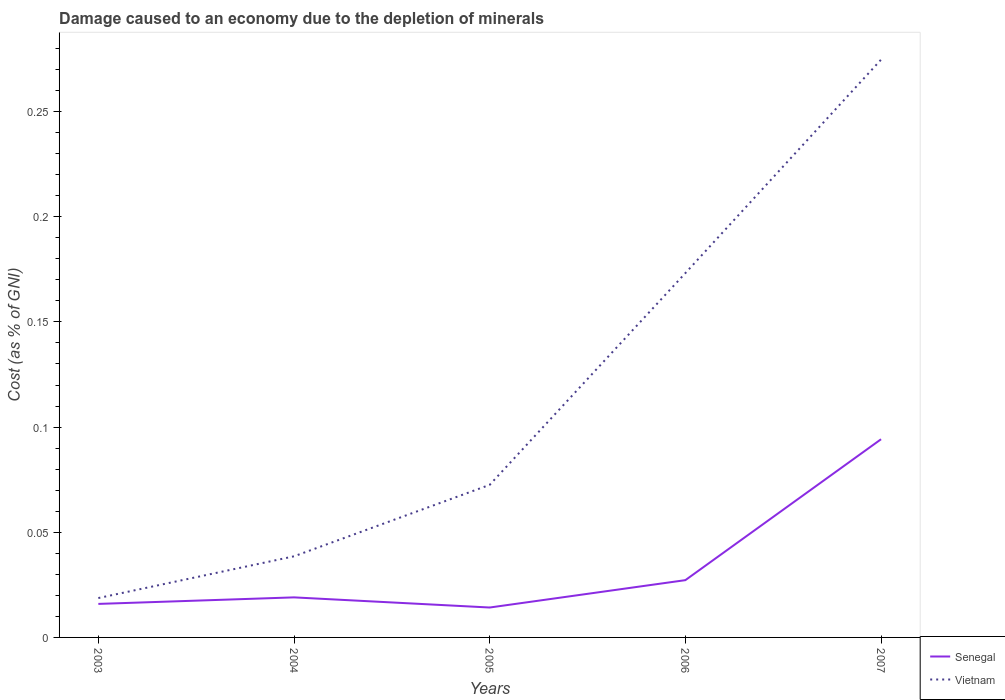Does the line corresponding to Vietnam intersect with the line corresponding to Senegal?
Ensure brevity in your answer.  No. Across all years, what is the maximum cost of damage caused due to the depletion of minerals in Vietnam?
Keep it short and to the point. 0.02. In which year was the cost of damage caused due to the depletion of minerals in Vietnam maximum?
Your answer should be very brief. 2003. What is the total cost of damage caused due to the depletion of minerals in Vietnam in the graph?
Give a very brief answer. -0.2. What is the difference between the highest and the second highest cost of damage caused due to the depletion of minerals in Vietnam?
Make the answer very short. 0.26. Is the cost of damage caused due to the depletion of minerals in Vietnam strictly greater than the cost of damage caused due to the depletion of minerals in Senegal over the years?
Your answer should be very brief. No. How many legend labels are there?
Offer a very short reply. 2. What is the title of the graph?
Your response must be concise. Damage caused to an economy due to the depletion of minerals. What is the label or title of the Y-axis?
Your answer should be compact. Cost (as % of GNI). What is the Cost (as % of GNI) in Senegal in 2003?
Offer a terse response. 0.02. What is the Cost (as % of GNI) of Vietnam in 2003?
Offer a very short reply. 0.02. What is the Cost (as % of GNI) in Senegal in 2004?
Give a very brief answer. 0.02. What is the Cost (as % of GNI) of Vietnam in 2004?
Offer a terse response. 0.04. What is the Cost (as % of GNI) in Senegal in 2005?
Make the answer very short. 0.01. What is the Cost (as % of GNI) in Vietnam in 2005?
Ensure brevity in your answer.  0.07. What is the Cost (as % of GNI) of Senegal in 2006?
Your answer should be compact. 0.03. What is the Cost (as % of GNI) in Vietnam in 2006?
Offer a very short reply. 0.17. What is the Cost (as % of GNI) in Senegal in 2007?
Give a very brief answer. 0.09. What is the Cost (as % of GNI) in Vietnam in 2007?
Offer a very short reply. 0.27. Across all years, what is the maximum Cost (as % of GNI) of Senegal?
Provide a short and direct response. 0.09. Across all years, what is the maximum Cost (as % of GNI) in Vietnam?
Your response must be concise. 0.27. Across all years, what is the minimum Cost (as % of GNI) in Senegal?
Keep it short and to the point. 0.01. Across all years, what is the minimum Cost (as % of GNI) in Vietnam?
Make the answer very short. 0.02. What is the total Cost (as % of GNI) in Senegal in the graph?
Provide a succinct answer. 0.17. What is the total Cost (as % of GNI) in Vietnam in the graph?
Offer a terse response. 0.58. What is the difference between the Cost (as % of GNI) in Senegal in 2003 and that in 2004?
Give a very brief answer. -0. What is the difference between the Cost (as % of GNI) in Vietnam in 2003 and that in 2004?
Offer a very short reply. -0.02. What is the difference between the Cost (as % of GNI) in Senegal in 2003 and that in 2005?
Your answer should be very brief. 0. What is the difference between the Cost (as % of GNI) of Vietnam in 2003 and that in 2005?
Offer a very short reply. -0.05. What is the difference between the Cost (as % of GNI) of Senegal in 2003 and that in 2006?
Keep it short and to the point. -0.01. What is the difference between the Cost (as % of GNI) in Vietnam in 2003 and that in 2006?
Offer a terse response. -0.15. What is the difference between the Cost (as % of GNI) of Senegal in 2003 and that in 2007?
Offer a terse response. -0.08. What is the difference between the Cost (as % of GNI) in Vietnam in 2003 and that in 2007?
Your answer should be compact. -0.26. What is the difference between the Cost (as % of GNI) of Senegal in 2004 and that in 2005?
Provide a succinct answer. 0. What is the difference between the Cost (as % of GNI) in Vietnam in 2004 and that in 2005?
Your response must be concise. -0.03. What is the difference between the Cost (as % of GNI) in Senegal in 2004 and that in 2006?
Provide a short and direct response. -0.01. What is the difference between the Cost (as % of GNI) of Vietnam in 2004 and that in 2006?
Your response must be concise. -0.13. What is the difference between the Cost (as % of GNI) of Senegal in 2004 and that in 2007?
Provide a short and direct response. -0.08. What is the difference between the Cost (as % of GNI) in Vietnam in 2004 and that in 2007?
Your answer should be very brief. -0.24. What is the difference between the Cost (as % of GNI) in Senegal in 2005 and that in 2006?
Make the answer very short. -0.01. What is the difference between the Cost (as % of GNI) in Vietnam in 2005 and that in 2006?
Offer a very short reply. -0.1. What is the difference between the Cost (as % of GNI) of Senegal in 2005 and that in 2007?
Your answer should be very brief. -0.08. What is the difference between the Cost (as % of GNI) in Vietnam in 2005 and that in 2007?
Your answer should be very brief. -0.2. What is the difference between the Cost (as % of GNI) of Senegal in 2006 and that in 2007?
Ensure brevity in your answer.  -0.07. What is the difference between the Cost (as % of GNI) of Vietnam in 2006 and that in 2007?
Give a very brief answer. -0.1. What is the difference between the Cost (as % of GNI) in Senegal in 2003 and the Cost (as % of GNI) in Vietnam in 2004?
Give a very brief answer. -0.02. What is the difference between the Cost (as % of GNI) of Senegal in 2003 and the Cost (as % of GNI) of Vietnam in 2005?
Offer a very short reply. -0.06. What is the difference between the Cost (as % of GNI) in Senegal in 2003 and the Cost (as % of GNI) in Vietnam in 2006?
Keep it short and to the point. -0.16. What is the difference between the Cost (as % of GNI) of Senegal in 2003 and the Cost (as % of GNI) of Vietnam in 2007?
Your answer should be very brief. -0.26. What is the difference between the Cost (as % of GNI) in Senegal in 2004 and the Cost (as % of GNI) in Vietnam in 2005?
Offer a terse response. -0.05. What is the difference between the Cost (as % of GNI) of Senegal in 2004 and the Cost (as % of GNI) of Vietnam in 2006?
Give a very brief answer. -0.15. What is the difference between the Cost (as % of GNI) in Senegal in 2004 and the Cost (as % of GNI) in Vietnam in 2007?
Keep it short and to the point. -0.26. What is the difference between the Cost (as % of GNI) in Senegal in 2005 and the Cost (as % of GNI) in Vietnam in 2006?
Your answer should be very brief. -0.16. What is the difference between the Cost (as % of GNI) of Senegal in 2005 and the Cost (as % of GNI) of Vietnam in 2007?
Ensure brevity in your answer.  -0.26. What is the difference between the Cost (as % of GNI) in Senegal in 2006 and the Cost (as % of GNI) in Vietnam in 2007?
Provide a succinct answer. -0.25. What is the average Cost (as % of GNI) of Senegal per year?
Ensure brevity in your answer.  0.03. What is the average Cost (as % of GNI) in Vietnam per year?
Make the answer very short. 0.12. In the year 2003, what is the difference between the Cost (as % of GNI) of Senegal and Cost (as % of GNI) of Vietnam?
Offer a terse response. -0. In the year 2004, what is the difference between the Cost (as % of GNI) in Senegal and Cost (as % of GNI) in Vietnam?
Provide a short and direct response. -0.02. In the year 2005, what is the difference between the Cost (as % of GNI) in Senegal and Cost (as % of GNI) in Vietnam?
Ensure brevity in your answer.  -0.06. In the year 2006, what is the difference between the Cost (as % of GNI) in Senegal and Cost (as % of GNI) in Vietnam?
Ensure brevity in your answer.  -0.15. In the year 2007, what is the difference between the Cost (as % of GNI) in Senegal and Cost (as % of GNI) in Vietnam?
Your response must be concise. -0.18. What is the ratio of the Cost (as % of GNI) of Senegal in 2003 to that in 2004?
Provide a succinct answer. 0.84. What is the ratio of the Cost (as % of GNI) in Vietnam in 2003 to that in 2004?
Give a very brief answer. 0.49. What is the ratio of the Cost (as % of GNI) in Senegal in 2003 to that in 2005?
Provide a short and direct response. 1.12. What is the ratio of the Cost (as % of GNI) of Vietnam in 2003 to that in 2005?
Give a very brief answer. 0.26. What is the ratio of the Cost (as % of GNI) in Senegal in 2003 to that in 2006?
Ensure brevity in your answer.  0.59. What is the ratio of the Cost (as % of GNI) of Vietnam in 2003 to that in 2006?
Make the answer very short. 0.11. What is the ratio of the Cost (as % of GNI) in Senegal in 2003 to that in 2007?
Ensure brevity in your answer.  0.17. What is the ratio of the Cost (as % of GNI) in Vietnam in 2003 to that in 2007?
Ensure brevity in your answer.  0.07. What is the ratio of the Cost (as % of GNI) of Senegal in 2004 to that in 2005?
Offer a terse response. 1.34. What is the ratio of the Cost (as % of GNI) of Vietnam in 2004 to that in 2005?
Ensure brevity in your answer.  0.53. What is the ratio of the Cost (as % of GNI) in Senegal in 2004 to that in 2006?
Provide a succinct answer. 0.7. What is the ratio of the Cost (as % of GNI) in Vietnam in 2004 to that in 2006?
Give a very brief answer. 0.22. What is the ratio of the Cost (as % of GNI) of Senegal in 2004 to that in 2007?
Give a very brief answer. 0.2. What is the ratio of the Cost (as % of GNI) of Vietnam in 2004 to that in 2007?
Ensure brevity in your answer.  0.14. What is the ratio of the Cost (as % of GNI) in Senegal in 2005 to that in 2006?
Keep it short and to the point. 0.52. What is the ratio of the Cost (as % of GNI) of Vietnam in 2005 to that in 2006?
Keep it short and to the point. 0.42. What is the ratio of the Cost (as % of GNI) in Senegal in 2005 to that in 2007?
Give a very brief answer. 0.15. What is the ratio of the Cost (as % of GNI) of Vietnam in 2005 to that in 2007?
Ensure brevity in your answer.  0.26. What is the ratio of the Cost (as % of GNI) of Senegal in 2006 to that in 2007?
Ensure brevity in your answer.  0.29. What is the ratio of the Cost (as % of GNI) of Vietnam in 2006 to that in 2007?
Keep it short and to the point. 0.63. What is the difference between the highest and the second highest Cost (as % of GNI) in Senegal?
Give a very brief answer. 0.07. What is the difference between the highest and the second highest Cost (as % of GNI) of Vietnam?
Your response must be concise. 0.1. What is the difference between the highest and the lowest Cost (as % of GNI) in Vietnam?
Provide a short and direct response. 0.26. 